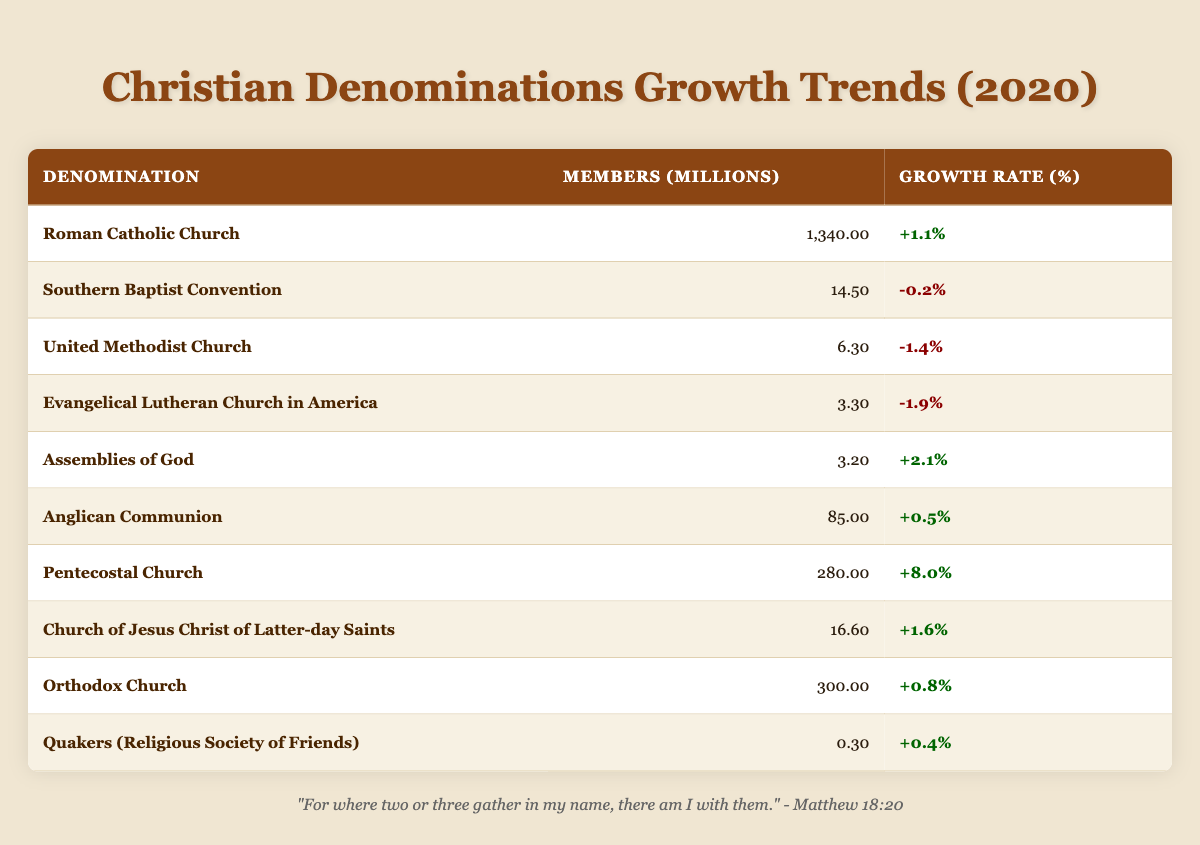What is the membership count of the Pentecostal Church? The membership count of the Pentecostal Church can be found in the "Members (Millions)" column of the table. It shows 280.0 million members.
Answer: 280.0 Which denomination has the highest growth rate in 2020? To find the highest growth rate, we can look through the "Growth Rate (%)" column. The Pentecostal Church has the highest growth rate at +8.0%.
Answer: Pentecostal Church What is the total number of members in the Southern Baptist Convention and the United Methodist Church combined? We need to find the membership counts of both denominations: Southern Baptist Convention has 14.5 million and United Methodist Church has 6.3 million. Adding these gives us 14.5 + 6.3 = 20.8 million.
Answer: 20.8 Did the Anglican Communion experience a negative growth rate in 2020? By checking the "Growth Rate (%)" column, we see that the Anglican Communion has a rate of +0.5%, which is not negative. The answer is no.
Answer: No If we average the membership numbers of the denominations with positive growth rates, what is the result? First, identify the denominations with positive growth: Roman Catholic Church (1340.0), Assemblies of God (3.2), Anglican Communion (85.0), Pentecostal Church (280.0), Church of Jesus Christ of Latter-day Saints (16.6), Orthodox Church (300.0), and Quakers (0.3). The total membership from these denominations is 1340.0 + 3.2 + 85.0 + 280.0 + 16.6 + 300.0 + 0.3 = 2025.1 million. There are 7 denominations, so 2025.1 / 7 = approximately 289.3 million.
Answer: 289.3 Which denomination has the lowest membership count? The membership counts of all denominations are listed. The lowest count is clearly from the Quakers (Religious Society of Friends) with 0.3 million members.
Answer: Quakers (Religious Society of Friends) 